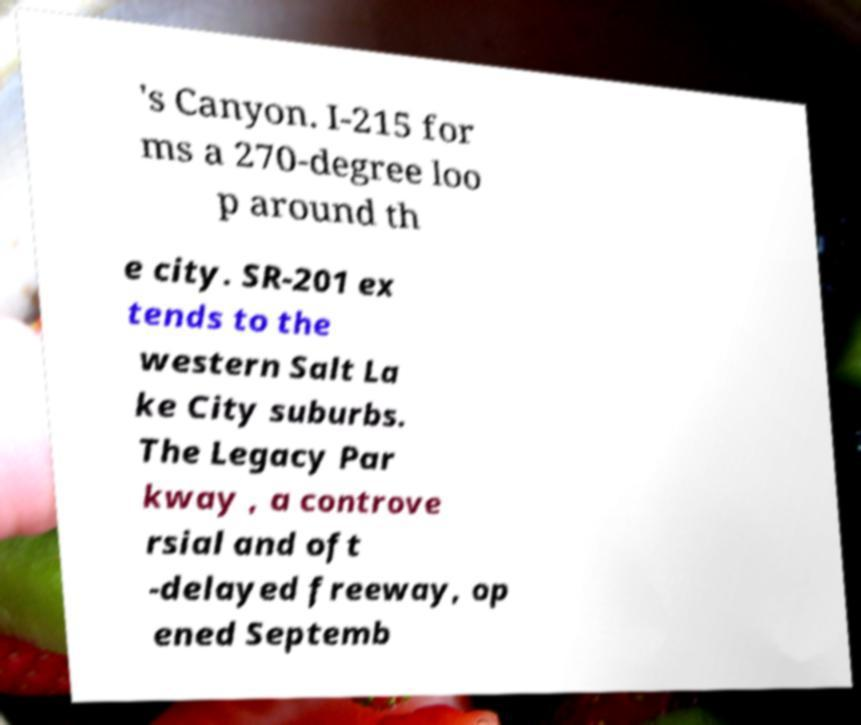Please read and relay the text visible in this image. What does it say? 's Canyon. I-215 for ms a 270-degree loo p around th e city. SR-201 ex tends to the western Salt La ke City suburbs. The Legacy Par kway , a controve rsial and oft -delayed freeway, op ened Septemb 